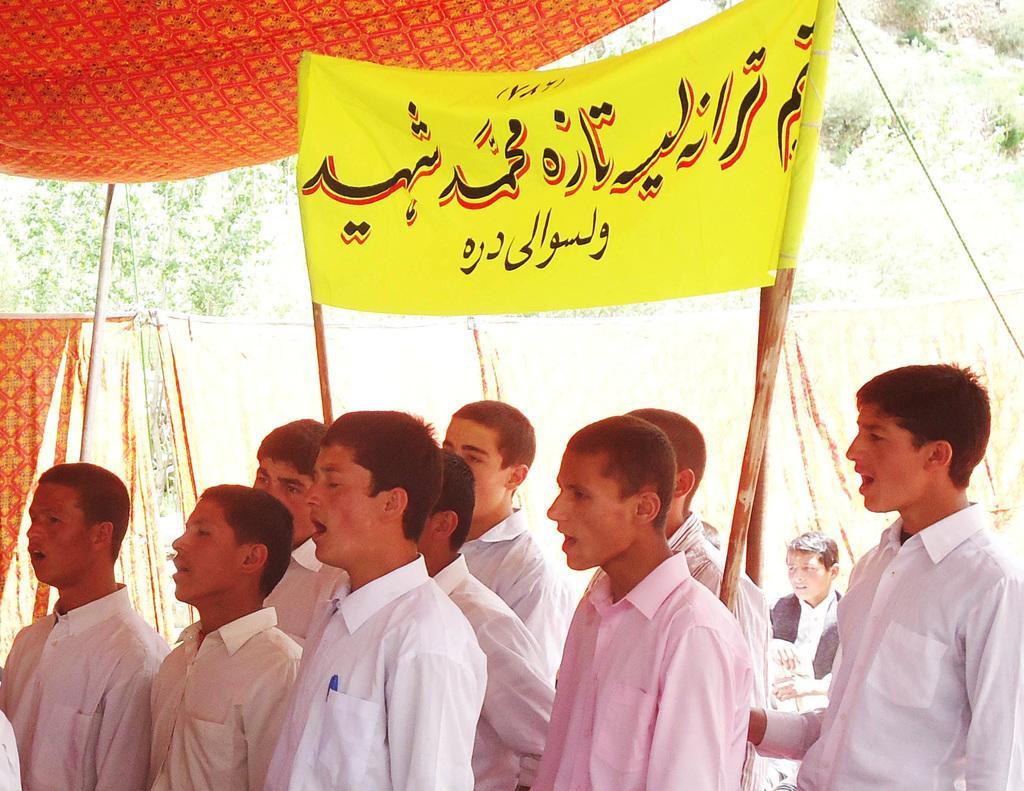How would you summarize this image in a sentence or two? At the bottom, we see the group of people are standing. I think they are singing the song. We see two men are holding wooden sticks and a banner in yellow color with some text written on it. All of them are standing under the red tent. Behind them, we see a man in black jacket is sitting. Behind them, we see sheets or clothes in red and yellow color. There are trees in the background. 